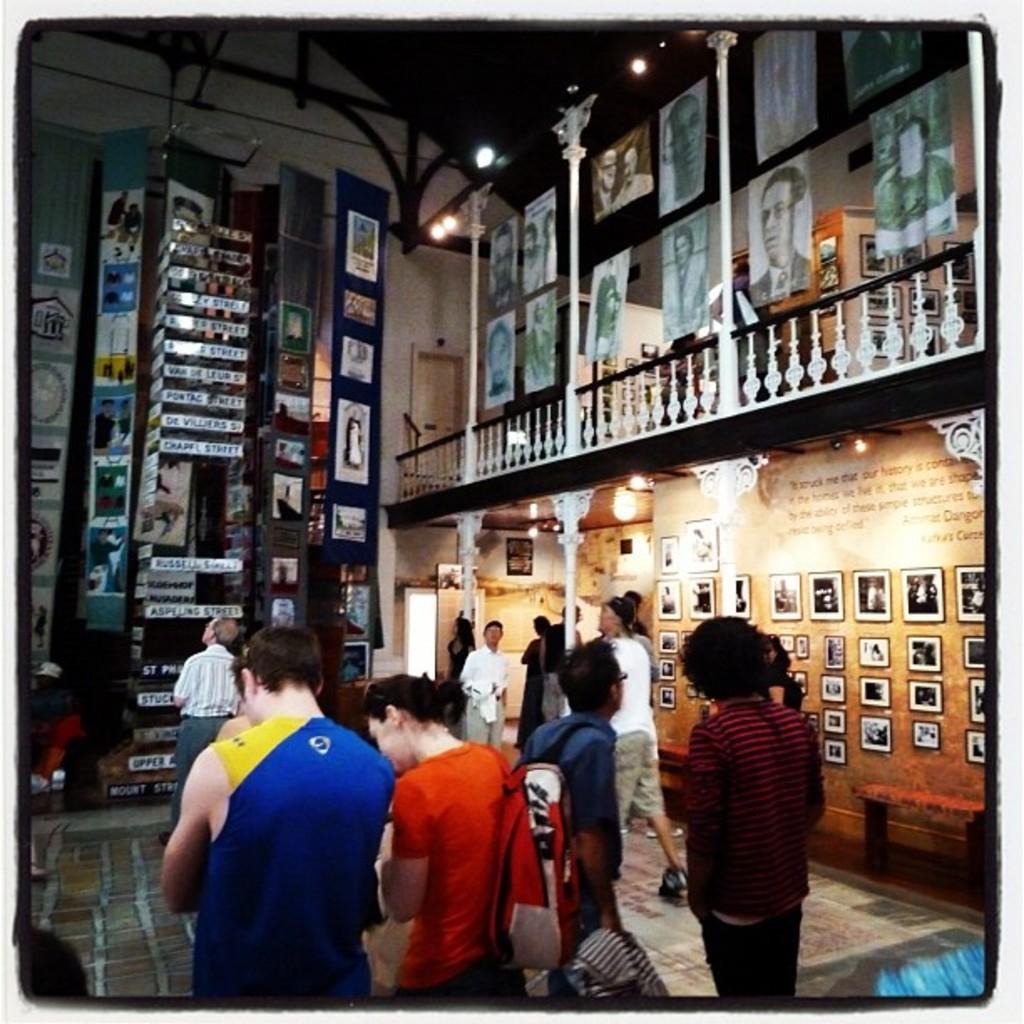How would you summarize this image in a sentence or two? In this image we can see many people. Some are holding bags. On the right side there are walls with photo frames. Also there are lights. And there are pillars and railings. In the back there are photo frames on the wall. And something is written on the boards. 